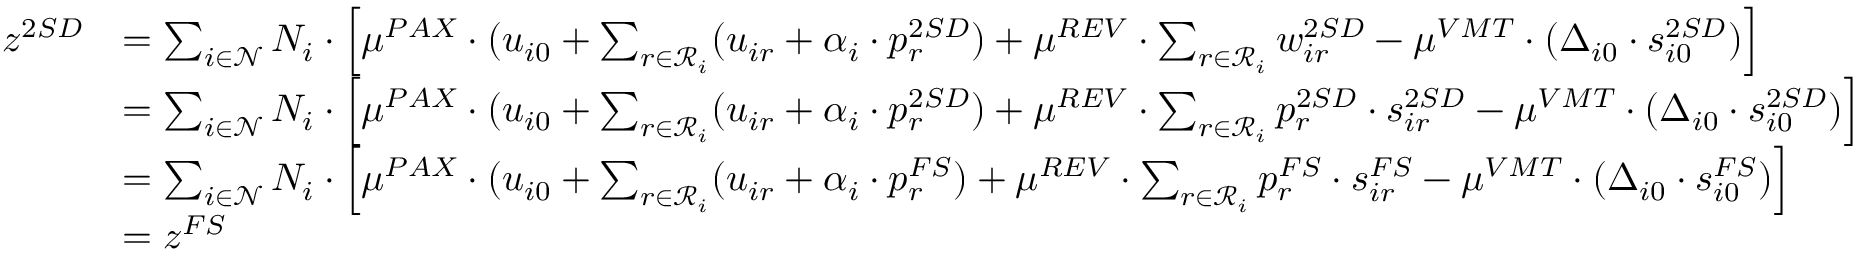<formula> <loc_0><loc_0><loc_500><loc_500>\begin{array} { r l } { z ^ { 2 S D } } & { = \sum _ { i \in \mathcal { N } } N _ { i } \cdot \left [ \mu ^ { P A X } \cdot ( u _ { i 0 } + \sum _ { r \in \mathcal { R } _ { i } } ( u _ { i r } + \alpha _ { i } \cdot p _ { r } ^ { 2 S D } ) + \mu ^ { R E V } \cdot \sum _ { r \in \mathcal { R } _ { i } } w _ { i r } ^ { 2 S D } - \mu ^ { V M T } \cdot ( \Delta _ { i 0 } \cdot s _ { i 0 } ^ { 2 S D } ) \right ] } \\ & { = \sum _ { i \in \mathcal { N } } N _ { i } \cdot \left [ \mu ^ { P A X } \cdot ( u _ { i 0 } + \sum _ { r \in \mathcal { R } _ { i } } ( u _ { i r } + \alpha _ { i } \cdot p _ { r } ^ { 2 S D } ) + \mu ^ { R E V } \cdot \sum _ { r \in \mathcal { R } _ { i } } p _ { r } ^ { 2 S D } \cdot s _ { i r } ^ { 2 S D } - \mu ^ { V M T } \cdot ( \Delta _ { i 0 } \cdot s _ { i 0 } ^ { 2 S D } ) \right ] } \\ & { = \sum _ { i \in \mathcal { N } } N _ { i } \cdot \left [ \mu ^ { P A X } \cdot ( u _ { i 0 } + \sum _ { r \in \mathcal { R } _ { i } } ( u _ { i r } + \alpha _ { i } \cdot p _ { r } ^ { F S } ) + \mu ^ { R E V } \cdot \sum _ { r \in \mathcal { R } _ { i } } p _ { r } ^ { F S } \cdot s _ { i r } ^ { F S } - \mu ^ { V M T } \cdot ( \Delta _ { i 0 } \cdot s _ { i 0 } ^ { F S } ) \right ] } \\ & { = z ^ { F S } } \end{array}</formula> 